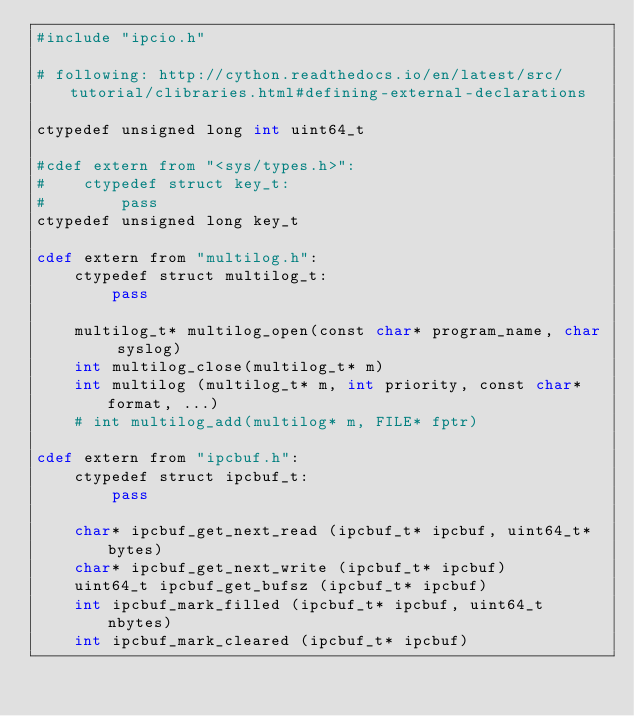<code> <loc_0><loc_0><loc_500><loc_500><_Cython_>#include "ipcio.h"

# following: http://cython.readthedocs.io/en/latest/src/tutorial/clibraries.html#defining-external-declarations

ctypedef unsigned long int uint64_t

#cdef extern from "<sys/types.h>":
#    ctypedef struct key_t:
#        pass
ctypedef unsigned long key_t

cdef extern from "multilog.h":
    ctypedef struct multilog_t:
        pass

    multilog_t* multilog_open(const char* program_name, char syslog)
    int multilog_close(multilog_t* m)
    int multilog (multilog_t* m, int priority, const char* format, ...)
    # int multilog_add(multilog* m, FILE* fptr)

cdef extern from "ipcbuf.h":
    ctypedef struct ipcbuf_t:
        pass

    char* ipcbuf_get_next_read (ipcbuf_t* ipcbuf, uint64_t* bytes)
    char* ipcbuf_get_next_write (ipcbuf_t* ipcbuf)
    uint64_t ipcbuf_get_bufsz (ipcbuf_t* ipcbuf)
    int ipcbuf_mark_filled (ipcbuf_t* ipcbuf, uint64_t nbytes)
    int ipcbuf_mark_cleared (ipcbuf_t* ipcbuf)</code> 